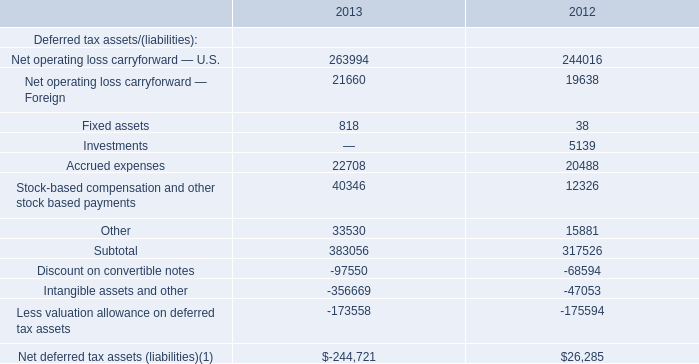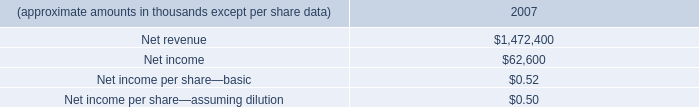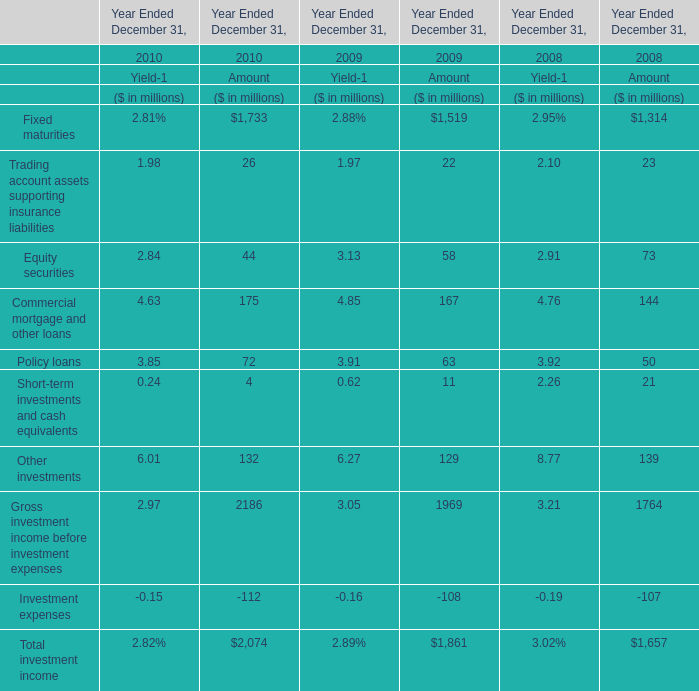what's the total amount of Net operating loss carryforward — U.S. of 2012, Net income of 2007, and Less valuation allowance on deferred tax assets of 2013 ? 
Computations: ((244016.0 + 62600.0) + 173558.0)
Answer: 480174.0. 